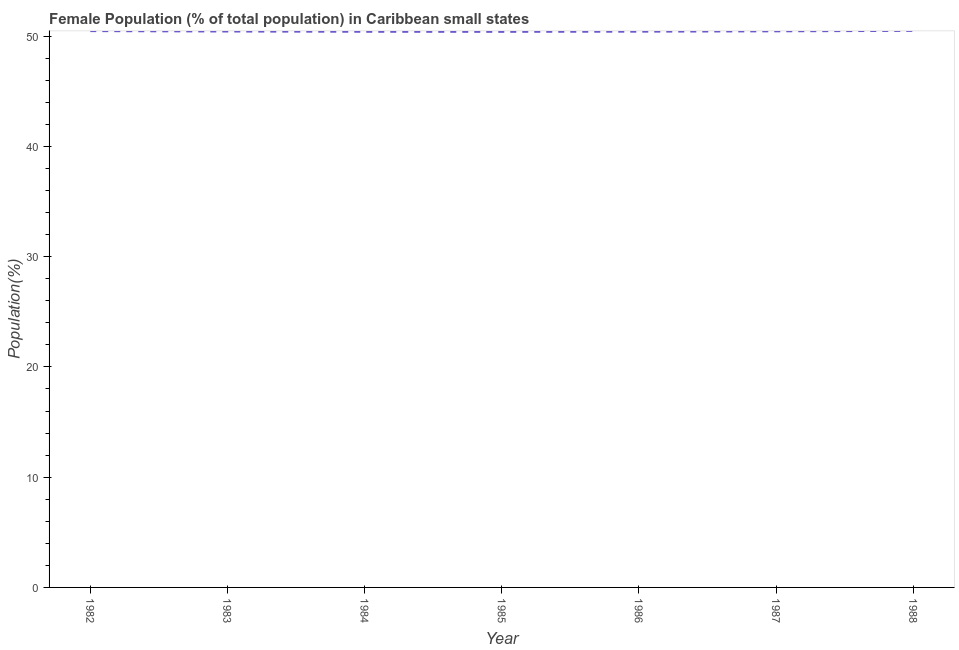What is the female population in 1986?
Your response must be concise. 50.41. Across all years, what is the maximum female population?
Ensure brevity in your answer.  50.48. Across all years, what is the minimum female population?
Offer a very short reply. 50.39. What is the sum of the female population?
Make the answer very short. 352.99. What is the difference between the female population in 1982 and 1987?
Give a very brief answer. 0.02. What is the average female population per year?
Keep it short and to the point. 50.43. What is the median female population?
Keep it short and to the point. 50.42. Do a majority of the years between 1987 and 1988 (inclusive) have female population greater than 12 %?
Provide a short and direct response. Yes. What is the ratio of the female population in 1982 to that in 1988?
Ensure brevity in your answer.  1. What is the difference between the highest and the second highest female population?
Ensure brevity in your answer.  0.02. Is the sum of the female population in 1982 and 1984 greater than the maximum female population across all years?
Provide a succinct answer. Yes. What is the difference between the highest and the lowest female population?
Keep it short and to the point. 0.09. In how many years, is the female population greater than the average female population taken over all years?
Make the answer very short. 3. How many lines are there?
Ensure brevity in your answer.  1. Are the values on the major ticks of Y-axis written in scientific E-notation?
Give a very brief answer. No. Does the graph contain any zero values?
Your response must be concise. No. Does the graph contain grids?
Your response must be concise. No. What is the title of the graph?
Your answer should be very brief. Female Population (% of total population) in Caribbean small states. What is the label or title of the Y-axis?
Your response must be concise. Population(%). What is the Population(%) of 1982?
Keep it short and to the point. 50.46. What is the Population(%) in 1983?
Offer a terse response. 50.42. What is the Population(%) of 1984?
Make the answer very short. 50.4. What is the Population(%) in 1985?
Your answer should be compact. 50.39. What is the Population(%) of 1986?
Your answer should be compact. 50.41. What is the Population(%) in 1987?
Keep it short and to the point. 50.44. What is the Population(%) in 1988?
Provide a succinct answer. 50.48. What is the difference between the Population(%) in 1982 and 1983?
Give a very brief answer. 0.04. What is the difference between the Population(%) in 1982 and 1984?
Your response must be concise. 0.06. What is the difference between the Population(%) in 1982 and 1985?
Offer a very short reply. 0.07. What is the difference between the Population(%) in 1982 and 1986?
Keep it short and to the point. 0.05. What is the difference between the Population(%) in 1982 and 1987?
Ensure brevity in your answer.  0.02. What is the difference between the Population(%) in 1982 and 1988?
Give a very brief answer. -0.02. What is the difference between the Population(%) in 1983 and 1984?
Provide a short and direct response. 0.02. What is the difference between the Population(%) in 1983 and 1985?
Make the answer very short. 0.03. What is the difference between the Population(%) in 1983 and 1986?
Your answer should be compact. 0.01. What is the difference between the Population(%) in 1983 and 1987?
Keep it short and to the point. -0.02. What is the difference between the Population(%) in 1983 and 1988?
Give a very brief answer. -0.06. What is the difference between the Population(%) in 1984 and 1985?
Your answer should be very brief. 0.01. What is the difference between the Population(%) in 1984 and 1986?
Ensure brevity in your answer.  -0.01. What is the difference between the Population(%) in 1984 and 1987?
Offer a very short reply. -0.04. What is the difference between the Population(%) in 1984 and 1988?
Offer a terse response. -0.08. What is the difference between the Population(%) in 1985 and 1986?
Offer a very short reply. -0.02. What is the difference between the Population(%) in 1985 and 1987?
Your response must be concise. -0.05. What is the difference between the Population(%) in 1985 and 1988?
Offer a very short reply. -0.09. What is the difference between the Population(%) in 1986 and 1987?
Your answer should be compact. -0.03. What is the difference between the Population(%) in 1986 and 1988?
Your response must be concise. -0.07. What is the difference between the Population(%) in 1987 and 1988?
Offer a very short reply. -0.04. What is the ratio of the Population(%) in 1982 to that in 1983?
Make the answer very short. 1. What is the ratio of the Population(%) in 1982 to that in 1987?
Offer a very short reply. 1. What is the ratio of the Population(%) in 1982 to that in 1988?
Give a very brief answer. 1. What is the ratio of the Population(%) in 1983 to that in 1984?
Offer a terse response. 1. What is the ratio of the Population(%) in 1983 to that in 1985?
Keep it short and to the point. 1. What is the ratio of the Population(%) in 1983 to that in 1988?
Make the answer very short. 1. What is the ratio of the Population(%) in 1985 to that in 1987?
Keep it short and to the point. 1. What is the ratio of the Population(%) in 1986 to that in 1987?
Provide a short and direct response. 1. What is the ratio of the Population(%) in 1987 to that in 1988?
Your answer should be very brief. 1. 